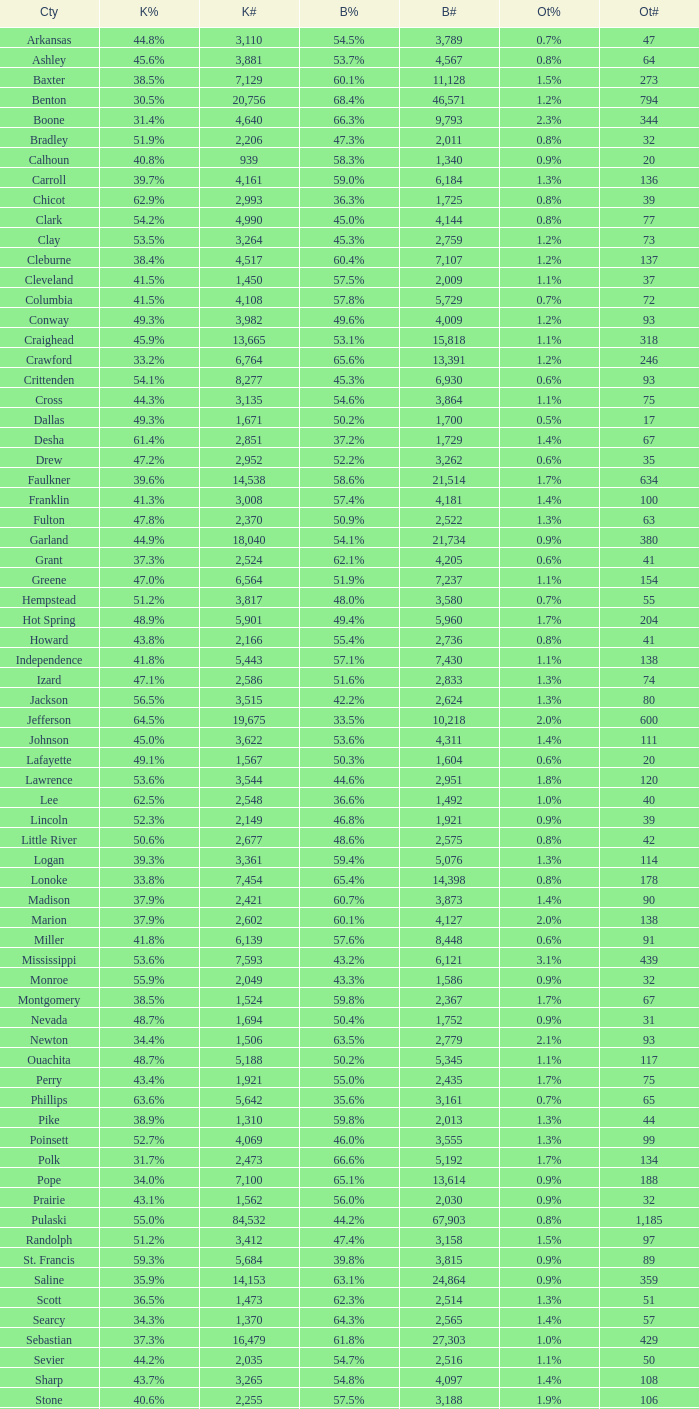What is the lowest Bush#, when Bush% is "65.4%"? 14398.0. 